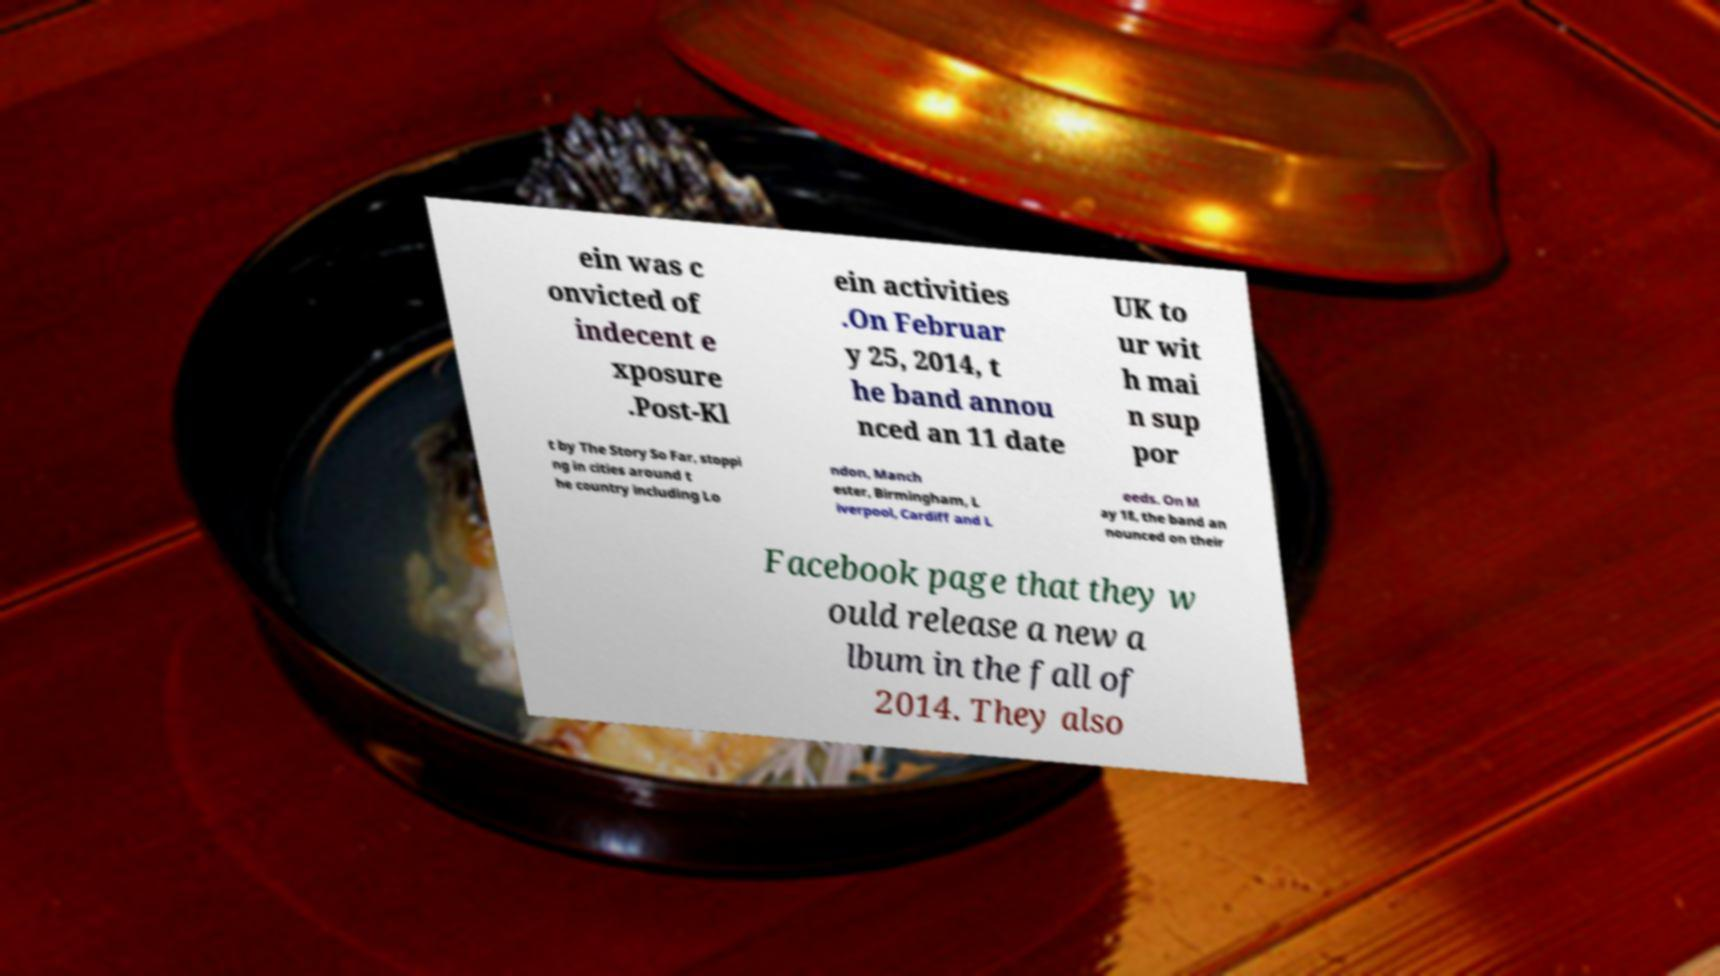There's text embedded in this image that I need extracted. Can you transcribe it verbatim? ein was c onvicted of indecent e xposure .Post-Kl ein activities .On Februar y 25, 2014, t he band annou nced an 11 date UK to ur wit h mai n sup por t by The Story So Far, stoppi ng in cities around t he country including Lo ndon, Manch ester, Birmingham, L iverpool, Cardiff and L eeds. On M ay 18, the band an nounced on their Facebook page that they w ould release a new a lbum in the fall of 2014. They also 